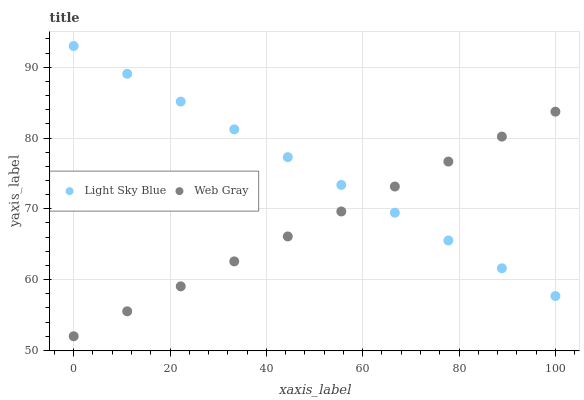Does Web Gray have the minimum area under the curve?
Answer yes or no. Yes. Does Light Sky Blue have the maximum area under the curve?
Answer yes or no. Yes. Does Web Gray have the maximum area under the curve?
Answer yes or no. No. Is Light Sky Blue the smoothest?
Answer yes or no. Yes. Is Web Gray the roughest?
Answer yes or no. Yes. Is Web Gray the smoothest?
Answer yes or no. No. Does Web Gray have the lowest value?
Answer yes or no. Yes. Does Light Sky Blue have the highest value?
Answer yes or no. Yes. Does Web Gray have the highest value?
Answer yes or no. No. Does Web Gray intersect Light Sky Blue?
Answer yes or no. Yes. Is Web Gray less than Light Sky Blue?
Answer yes or no. No. Is Web Gray greater than Light Sky Blue?
Answer yes or no. No. 